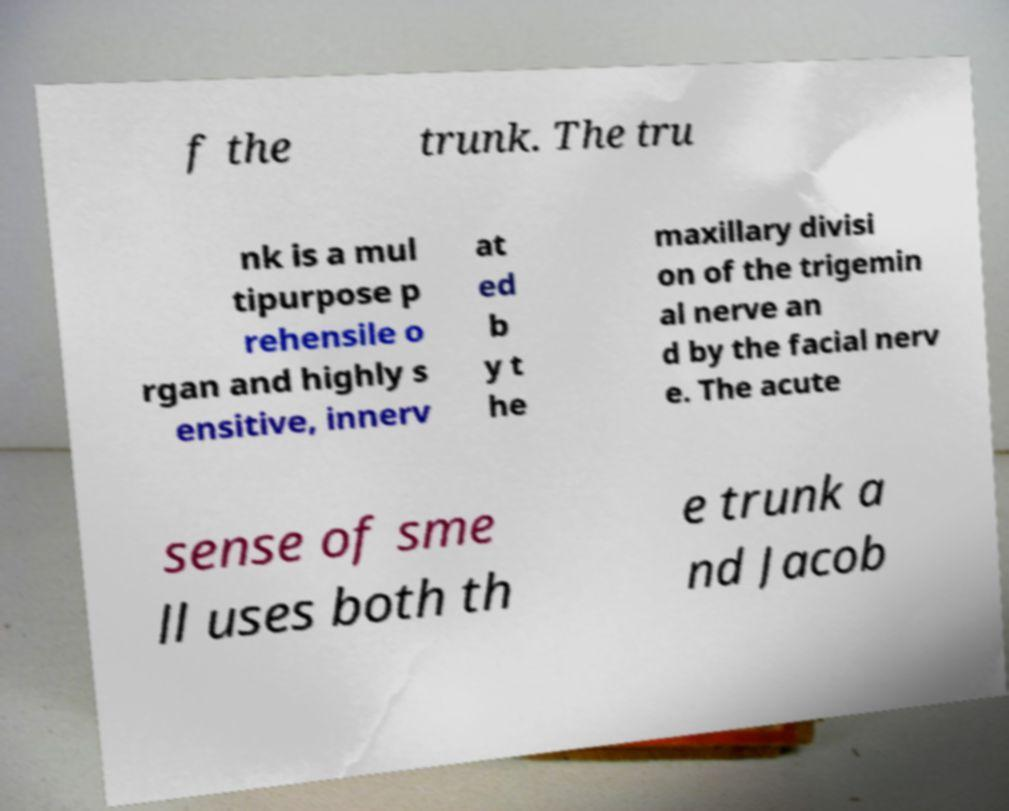Could you extract and type out the text from this image? f the trunk. The tru nk is a mul tipurpose p rehensile o rgan and highly s ensitive, innerv at ed b y t he maxillary divisi on of the trigemin al nerve an d by the facial nerv e. The acute sense of sme ll uses both th e trunk a nd Jacob 